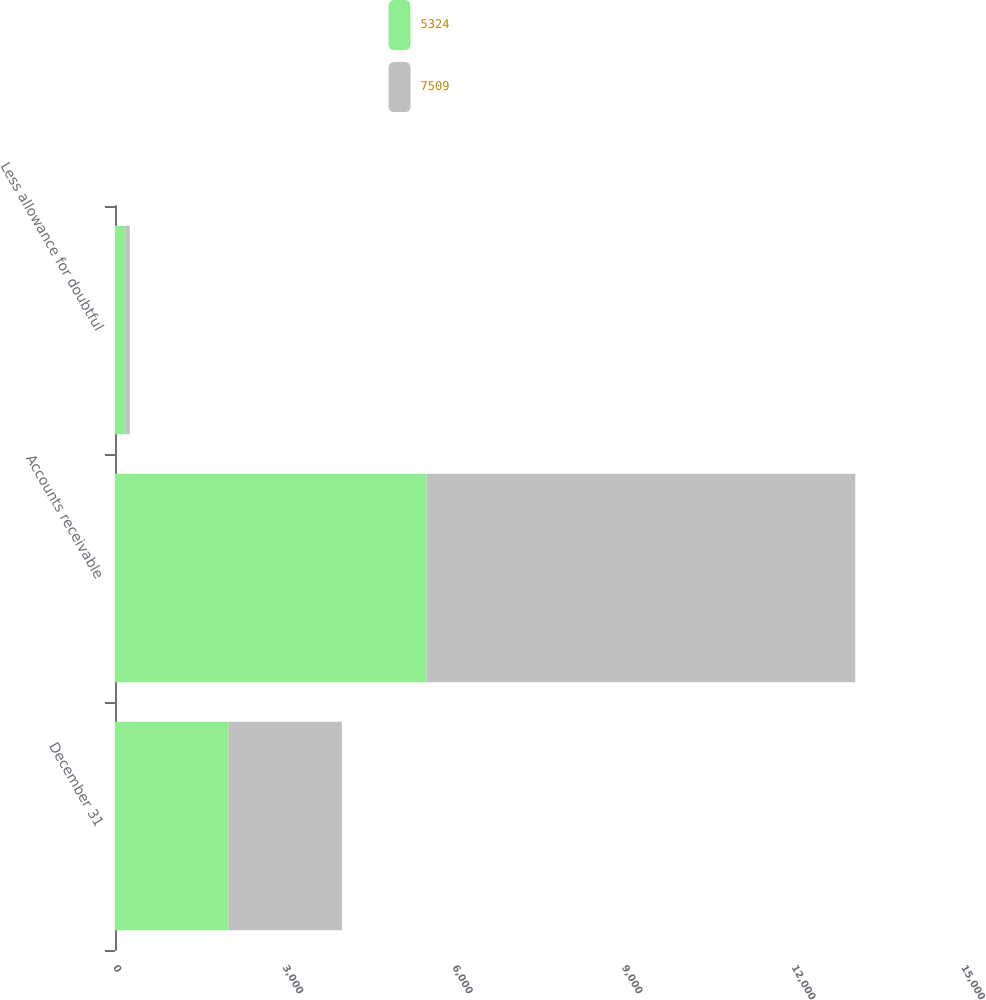Convert chart. <chart><loc_0><loc_0><loc_500><loc_500><stacked_bar_chart><ecel><fcel>December 31<fcel>Accounts receivable<fcel>Less allowance for doubtful<nl><fcel>5324<fcel>2007<fcel>5508<fcel>184<nl><fcel>7509<fcel>2006<fcel>7587<fcel>78<nl></chart> 